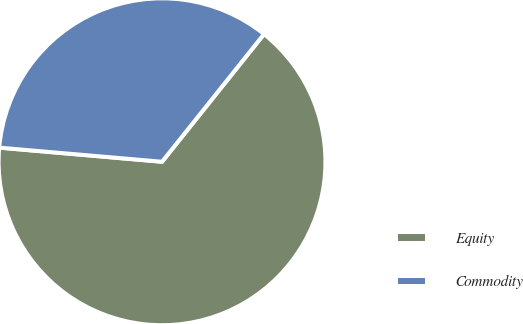Convert chart to OTSL. <chart><loc_0><loc_0><loc_500><loc_500><pie_chart><fcel>Equity<fcel>Commodity<nl><fcel>65.65%<fcel>34.35%<nl></chart> 